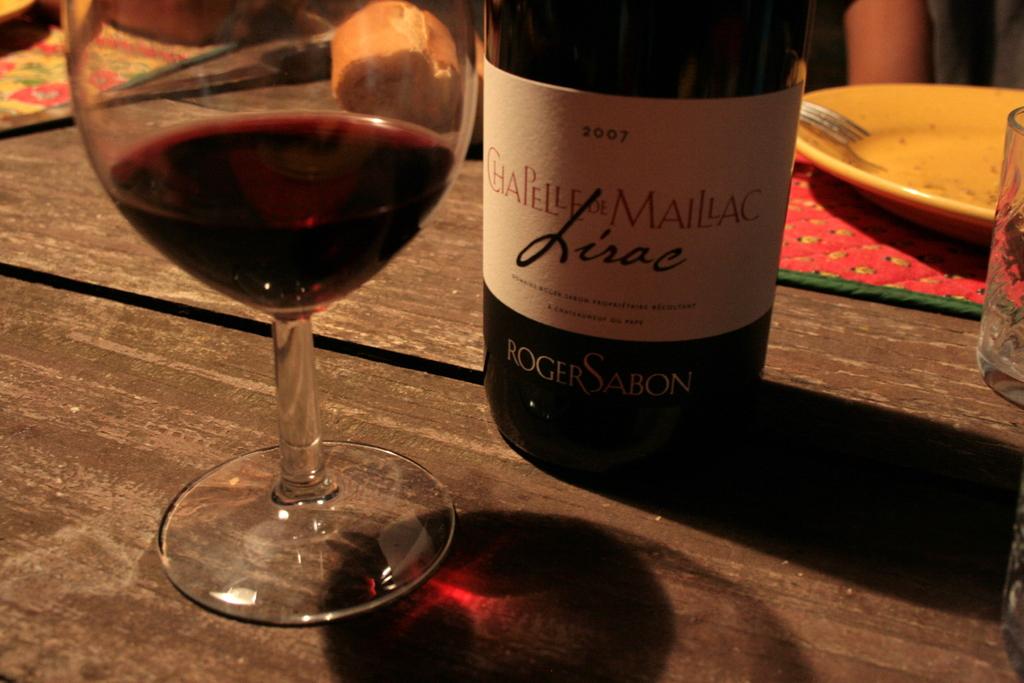What year is the wine?
Your response must be concise. 2007. Who made this wine?
Offer a terse response. Roger sabon. 